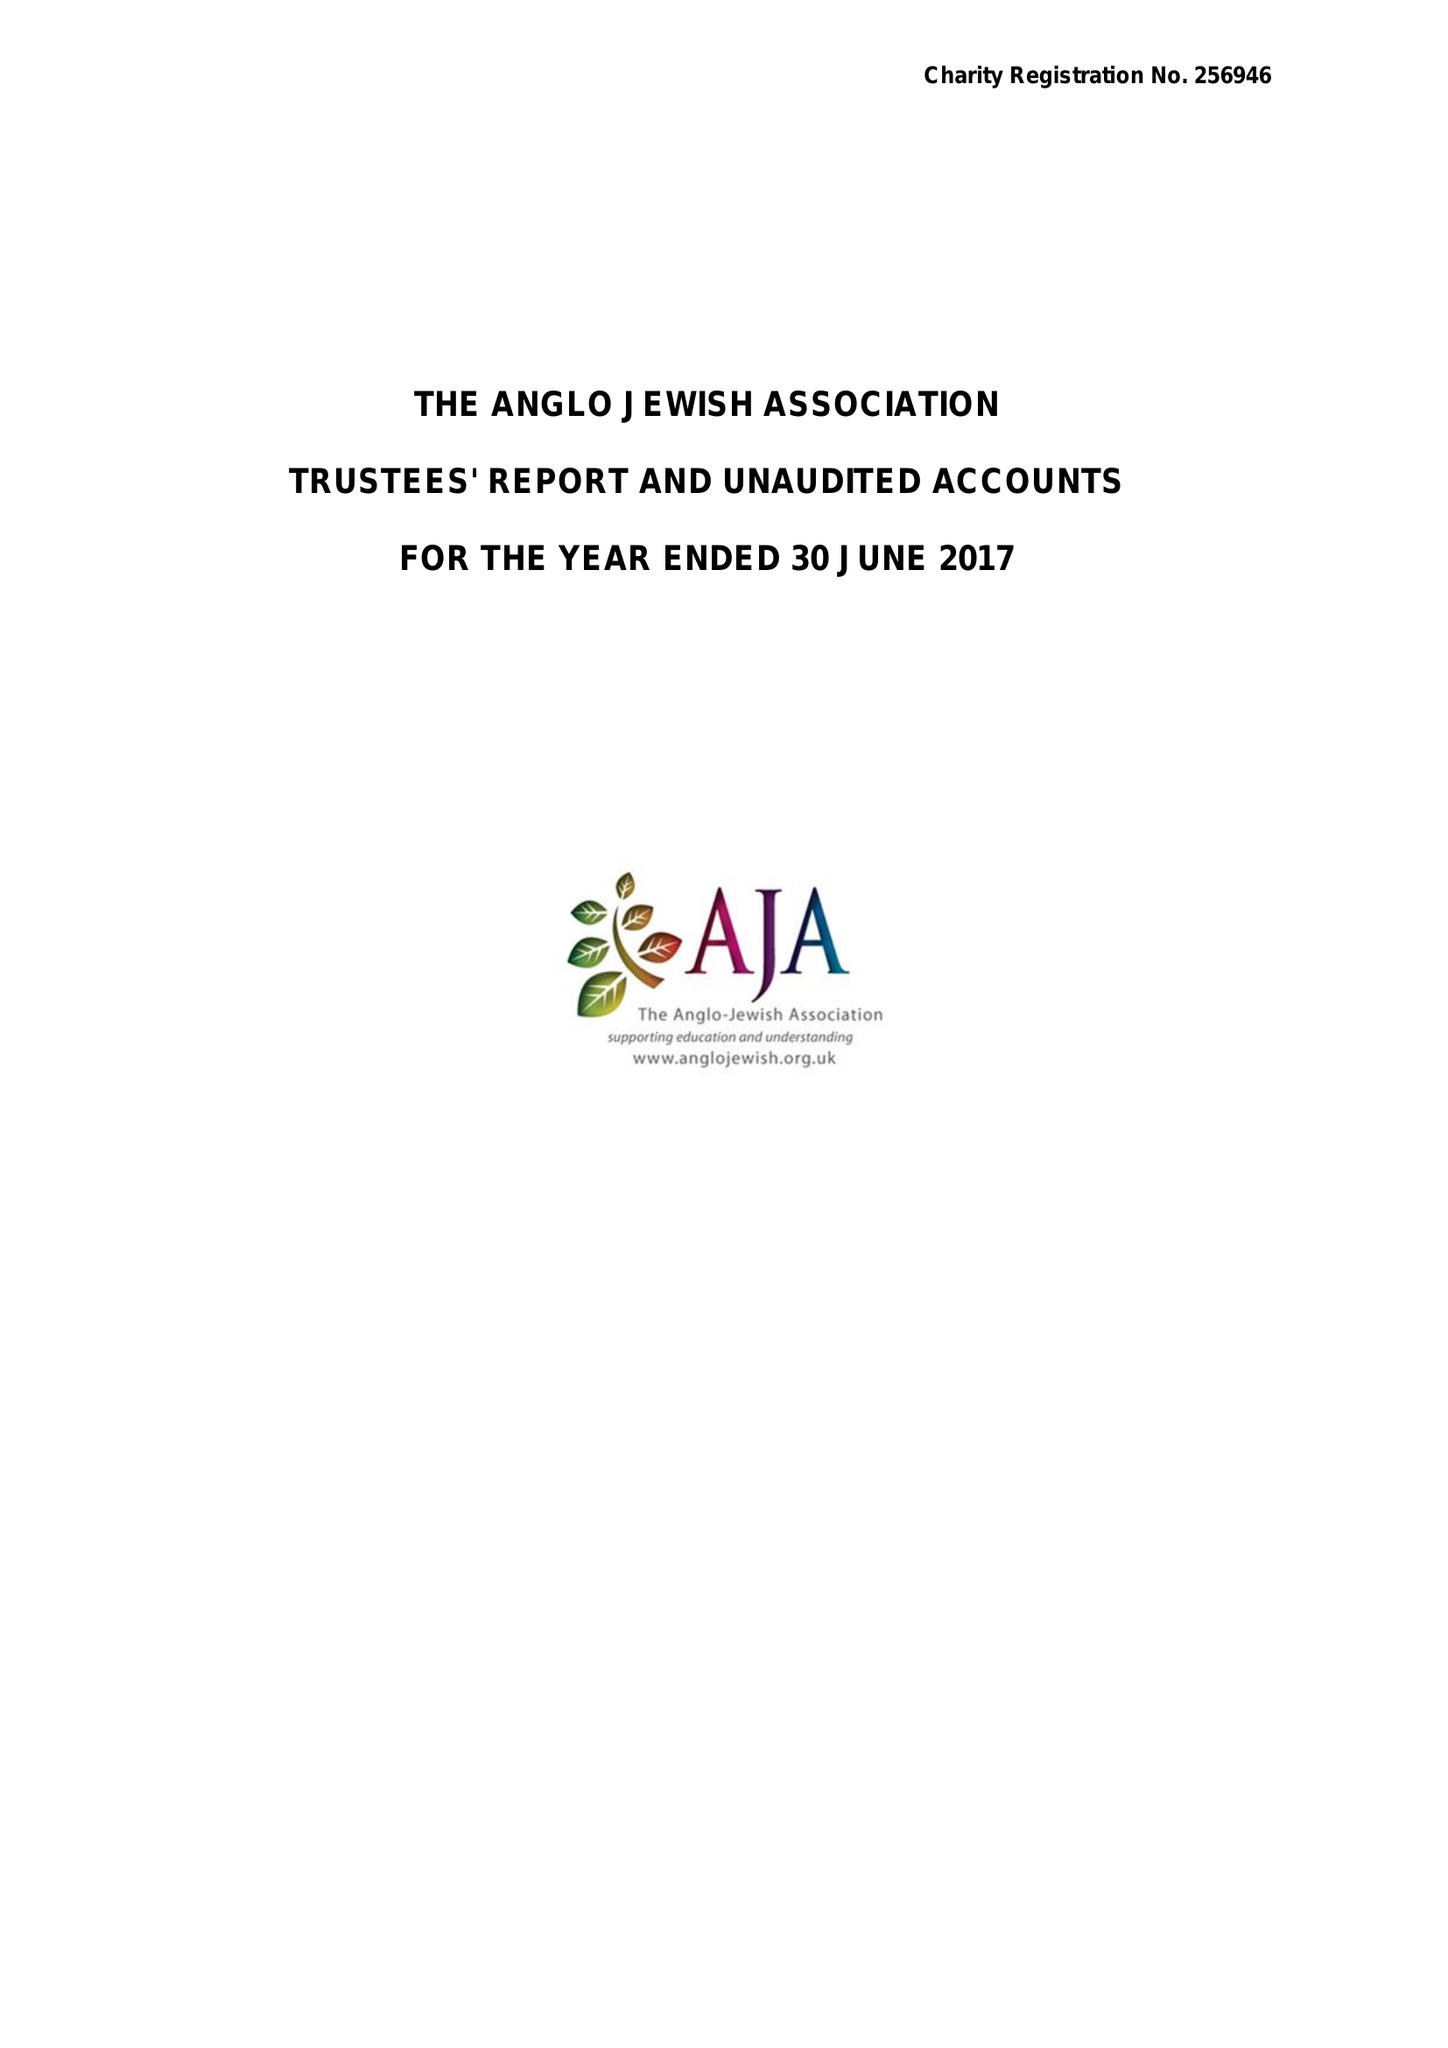What is the value for the address__postcode?
Answer the question using a single word or phrase. NW6 2EG 